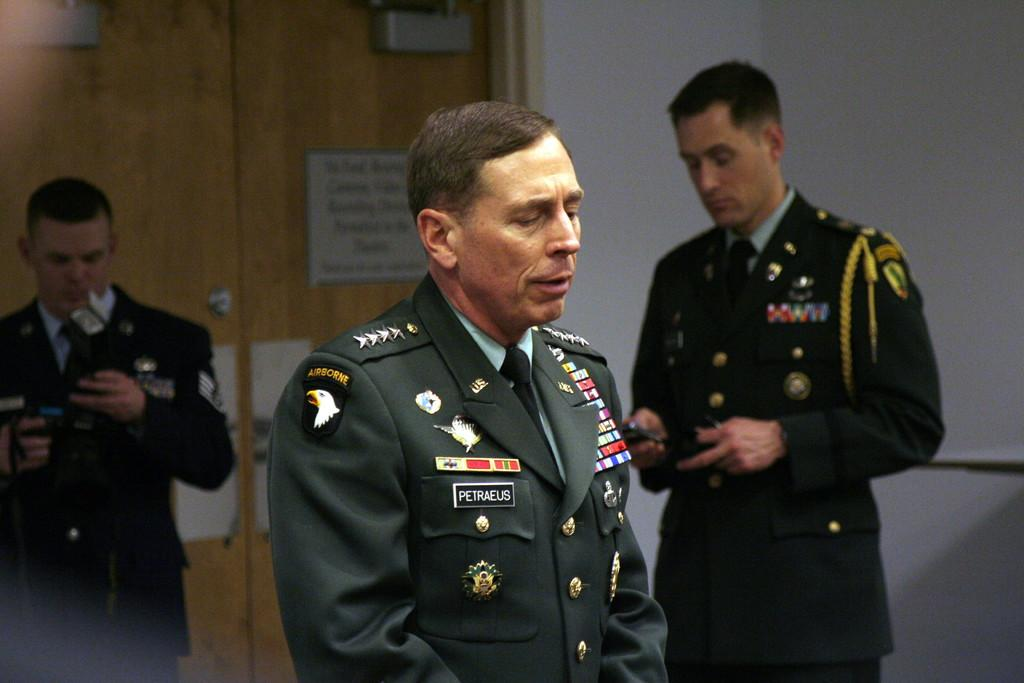How many men are in the image? There are three men in the image. What are the men doing in the image? The men are standing in the image. What are the men wearing? The men are wearing uniforms in the image. What can be seen in the background of the image? There is a wall, a door, and a board in the background of the image. Can you describe the river flowing in the background of the image? There is no river present in the image; the background features a wall, a door, and a board. 